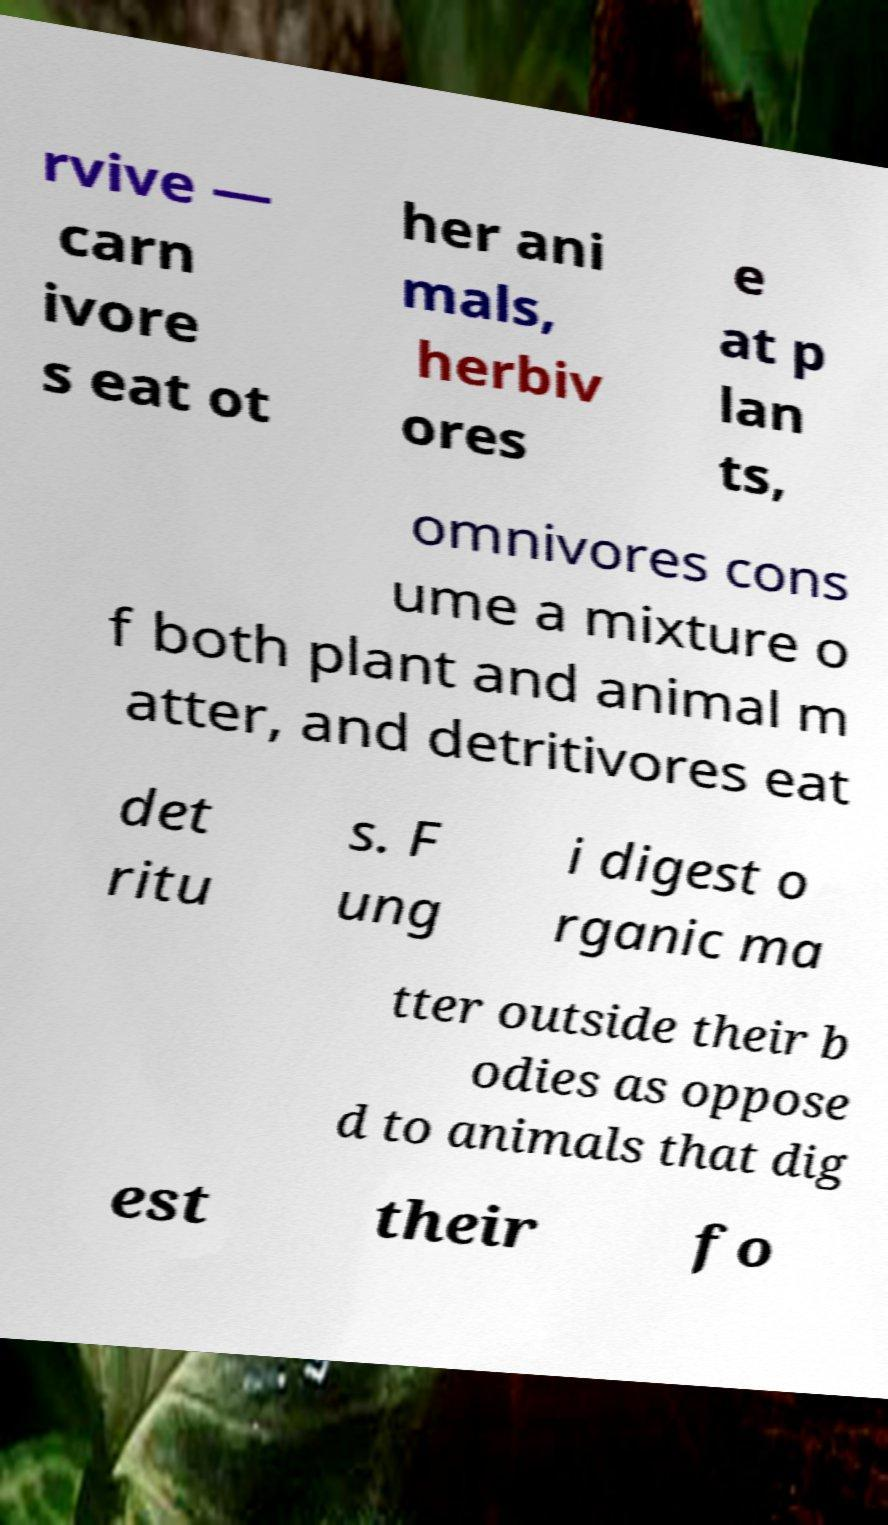Please identify and transcribe the text found in this image. rvive — carn ivore s eat ot her ani mals, herbiv ores e at p lan ts, omnivores cons ume a mixture o f both plant and animal m atter, and detritivores eat det ritu s. F ung i digest o rganic ma tter outside their b odies as oppose d to animals that dig est their fo 